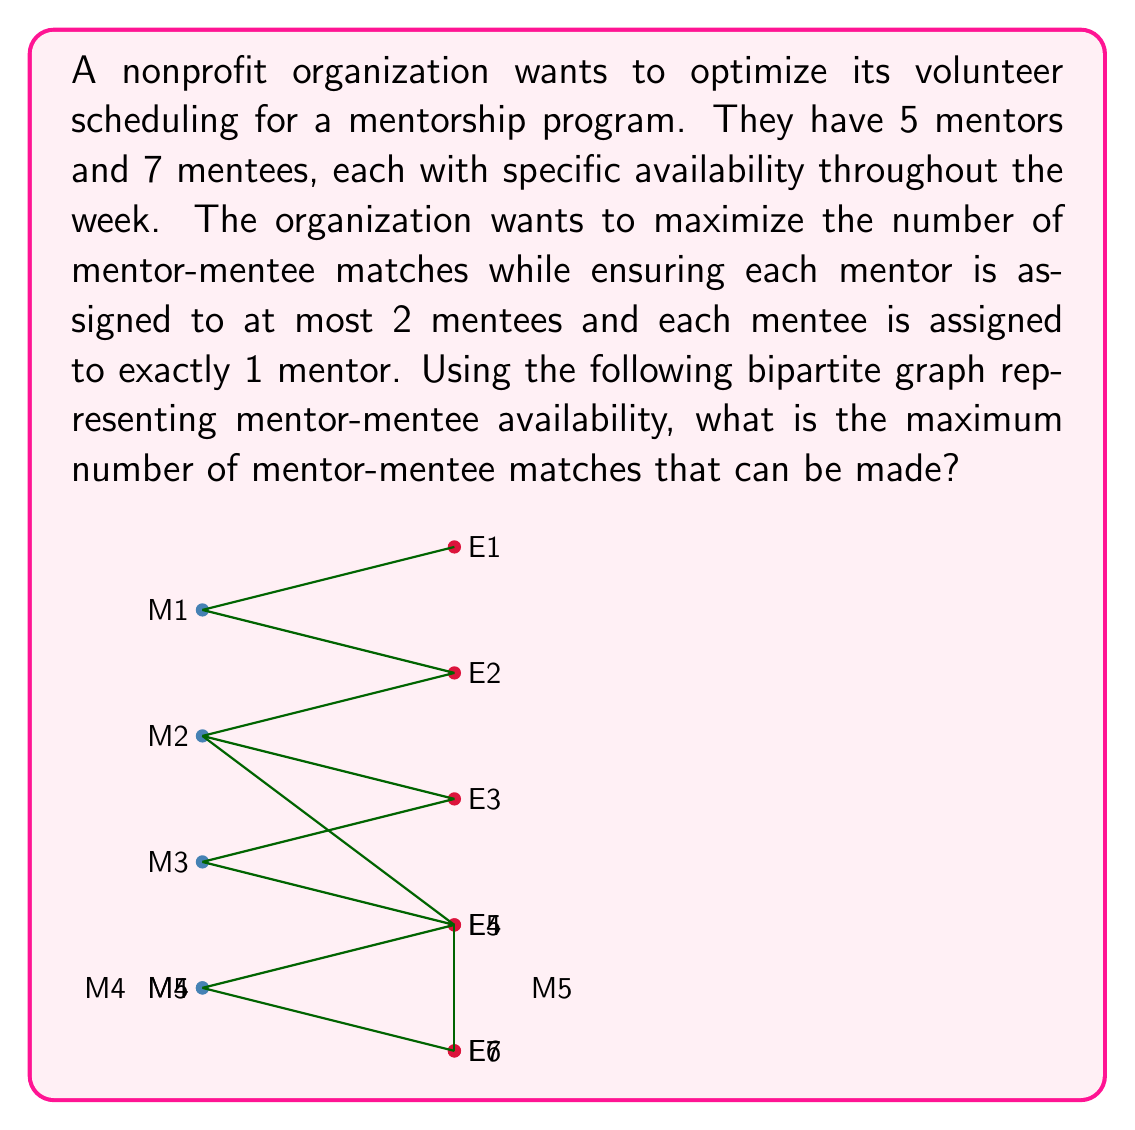Can you answer this question? To solve this problem, we can use the maximum flow algorithm on a modified network. Here's the step-by-step solution:

1) First, we need to construct a flow network from the given bipartite graph:
   - Add a source node S connected to all mentor nodes with capacity 2 (since each mentor can be assigned to at most 2 mentees).
   - Add a sink node T connected to all mentee nodes with capacity 1 (since each mentee must be assigned to exactly 1 mentor).
   - Set the capacity of all edges between mentors and mentees to 1.

2) The resulting network will look like this (capacities are shown on edges):

   S --(2)--> M1 --(1)--> E1 --(1)--> T
     --(2)--> M2 --(1)--> E2 --(1)--> T
     --(2)--> M3 --(1)--> E3 --(1)--> T
     --(2)--> M4 --(1)--> E4 --(1)--> T
     --(2)--> M5 --(1)--> E5 --(1)--> T
                          E6 --(1)--> T
                          E7 --(1)--> T

   (Note: Only edges present in the original graph are included between mentors and mentees)

3) Now we can apply the Ford-Fulkerson algorithm or any other max-flow algorithm to find the maximum flow in this network.

4) The algorithm will find the following augmenting paths:
   - S -> M1 -> E1 -> T (flow: 1)
   - S -> M1 -> E2 -> T (flow: 1)
   - S -> M2 -> E3 -> T (flow: 1)
   - S -> M3 -> E4 -> T (flow: 1)
   - S -> M4 -> E5 -> T (flow: 1)
   - S -> M5 -> E6 -> T (flow: 1)

5) After these paths are saturated, no more augmenting paths exist.

6) The maximum flow (which equals the maximum number of mentor-mentee matches) is the sum of the flows: 1 + 1 + 1 + 1 + 1 + 1 = 6.

Therefore, the maximum number of mentor-mentee matches that can be made is 6.
Answer: 6 